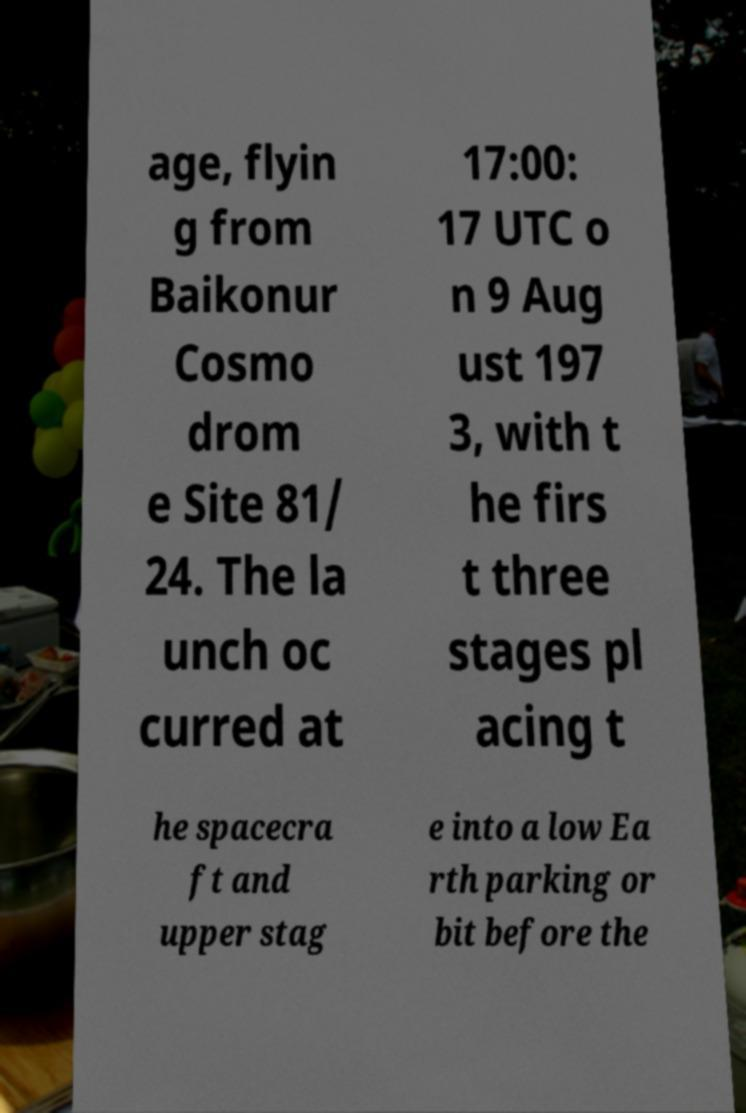Please read and relay the text visible in this image. What does it say? age, flyin g from Baikonur Cosmo drom e Site 81/ 24. The la unch oc curred at 17:00: 17 UTC o n 9 Aug ust 197 3, with t he firs t three stages pl acing t he spacecra ft and upper stag e into a low Ea rth parking or bit before the 